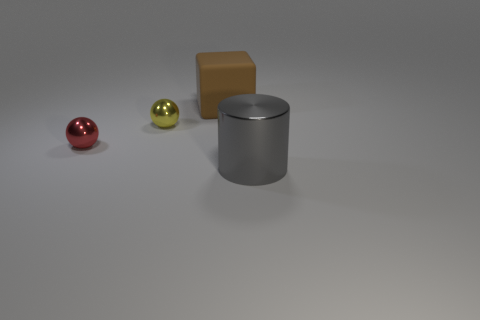Add 3 gray objects. How many objects exist? 7 Subtract all cylinders. How many objects are left? 3 Subtract all tiny yellow balls. Subtract all large cylinders. How many objects are left? 2 Add 2 tiny yellow spheres. How many tiny yellow spheres are left? 3 Add 2 small shiny objects. How many small shiny objects exist? 4 Subtract 0 blue cylinders. How many objects are left? 4 